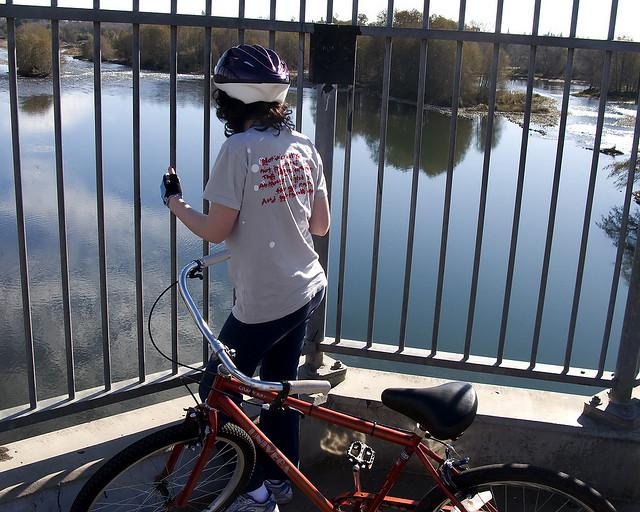Are there any animals?
Give a very brief answer. No. What is the boy doing?
Answer briefly. Looking at water. What color is the bike?
Give a very brief answer. Red. 